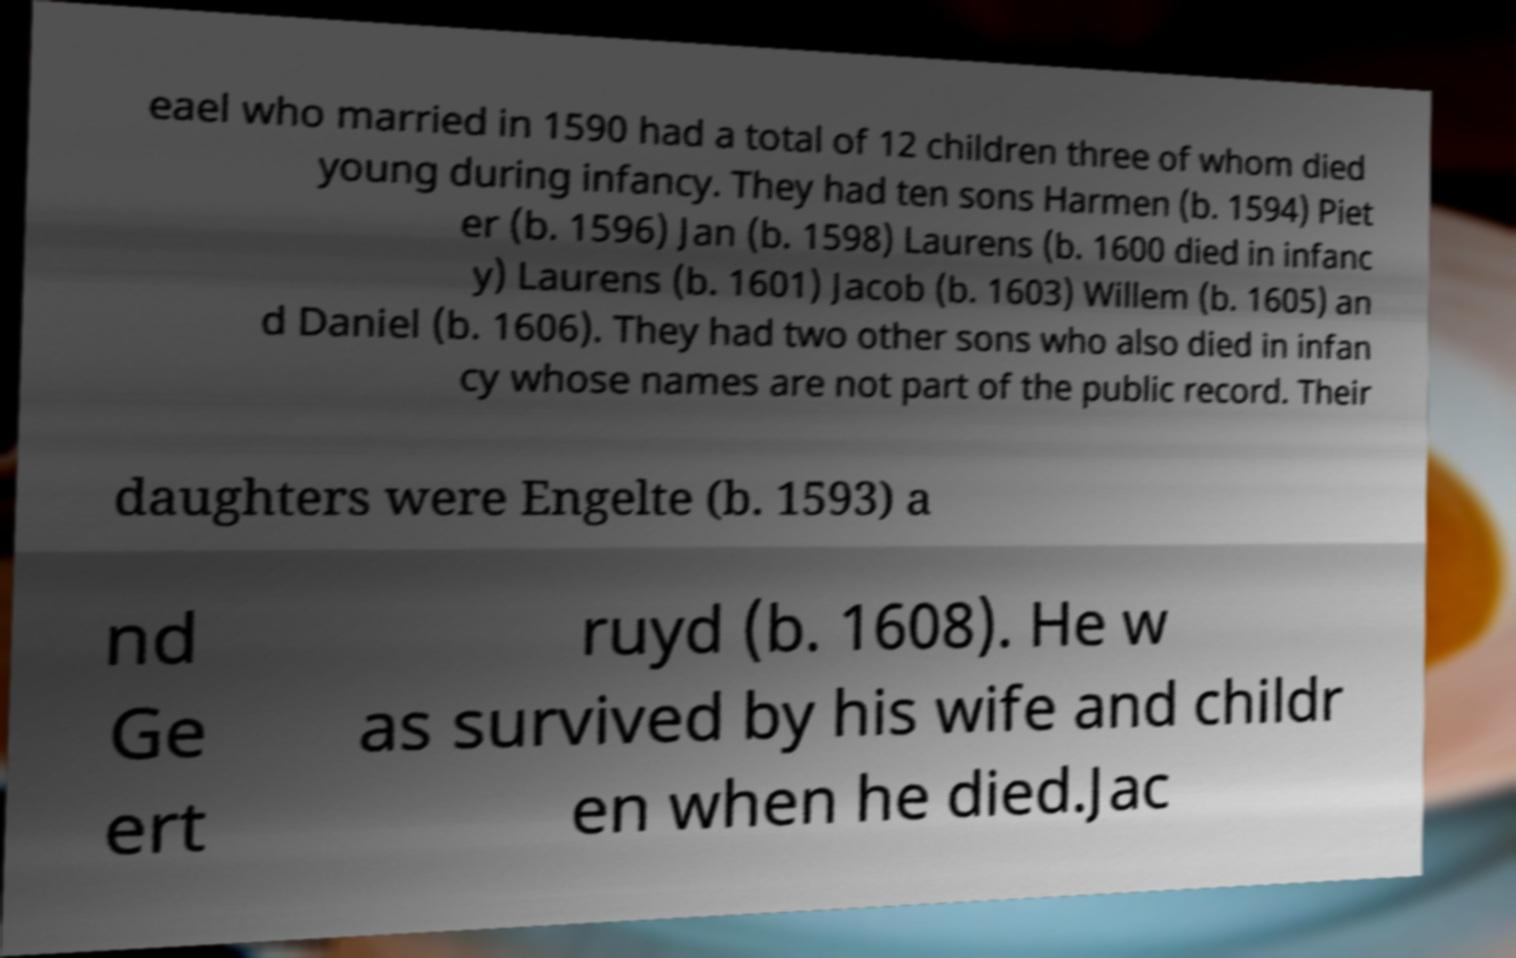I need the written content from this picture converted into text. Can you do that? eael who married in 1590 had a total of 12 children three of whom died young during infancy. They had ten sons Harmen (b. 1594) Piet er (b. 1596) Jan (b. 1598) Laurens (b. 1600 died in infanc y) Laurens (b. 1601) Jacob (b. 1603) Willem (b. 1605) an d Daniel (b. 1606). They had two other sons who also died in infan cy whose names are not part of the public record. Their daughters were Engelte (b. 1593) a nd Ge ert ruyd (b. 1608). He w as survived by his wife and childr en when he died.Jac 